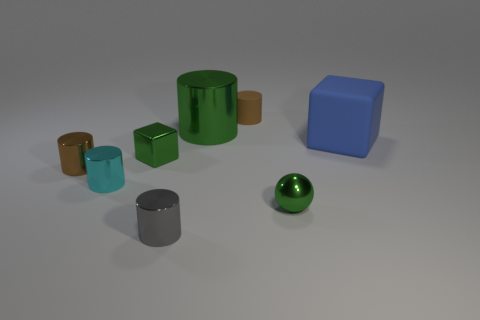There is a thing that is both behind the metallic cube and in front of the large green cylinder; what size is it?
Keep it short and to the point. Large. There is a big object that is the same shape as the tiny brown rubber thing; what is its color?
Ensure brevity in your answer.  Green. There is a block that is to the right of the metallic object that is behind the big blue matte block; what is its color?
Your answer should be very brief. Blue. There is a big matte object; what shape is it?
Offer a very short reply. Cube. There is a thing that is both in front of the tiny cyan cylinder and to the right of the tiny gray metallic thing; what is its shape?
Your response must be concise. Sphere. What is the color of the sphere that is made of the same material as the tiny gray cylinder?
Provide a succinct answer. Green. What is the shape of the green metal thing that is in front of the cube on the left side of the metal thing that is in front of the metal sphere?
Provide a short and direct response. Sphere. The brown metallic object is what size?
Give a very brief answer. Small. What shape is the small cyan thing that is made of the same material as the big green thing?
Your answer should be very brief. Cylinder. Are there fewer large green cylinders in front of the green shiny ball than large yellow cylinders?
Ensure brevity in your answer.  No. 